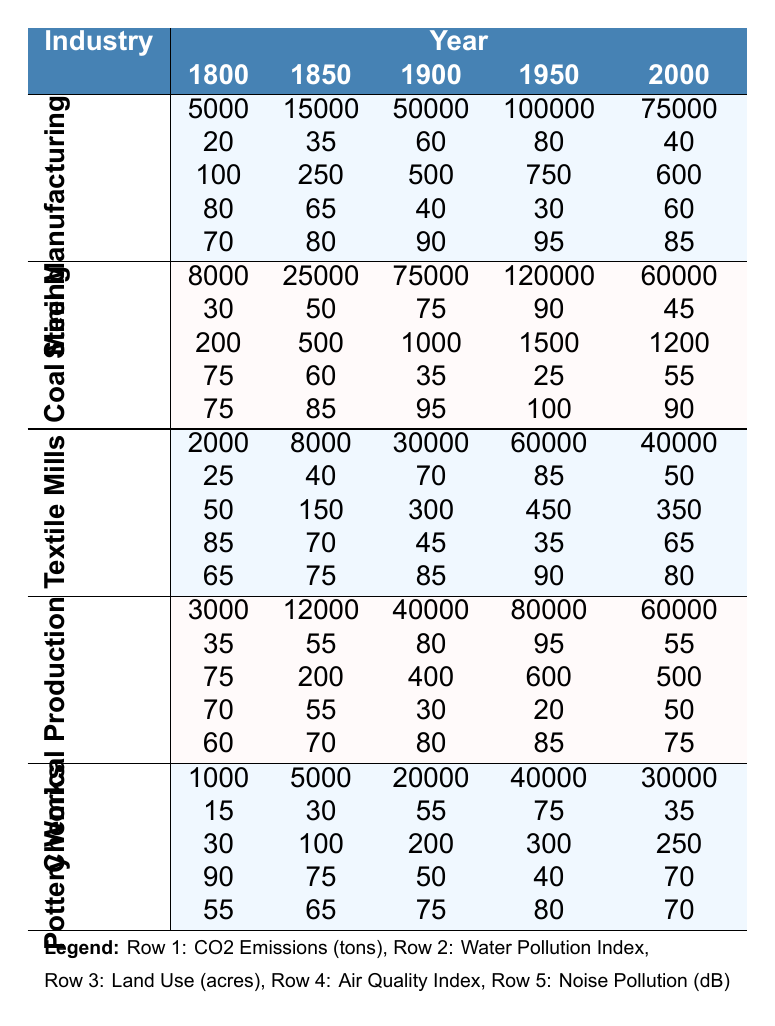What were the CO2 emissions of the Coal Mining industry in 1950? The table indicates that the CO2 emissions for Coal Mining in 1950 are 120,000 tons.
Answer: 120000 tons Which industry had the highest air quality index in 1800? The table shows that Pottery Works had the highest air quality index in 1800, with a value of 90.
Answer: Pottery Works What is the difference in CO2 emissions between Steel Manufacturing in 1900 and in 2000? Steel Manufacturing emitted 50,000 tons in 1900 and 75,000 tons in 2000. The difference is 75,000 - 50,000 = 25,000 tons.
Answer: 25000 tons In which year did Chemical Production record its highest noise pollution levels? Chemical Production reached its highest noise pollution levels of 85 dB in 1950.
Answer: 1950 What is the average water pollution index for Textile Mills across all years? The water pollution indices for Textile Mills are 25, 40, 70, 85, and 50. The average is (25 + 40 + 70 + 85 + 50)/5 = 54.
Answer: 54 Did Coal Mining have a water pollution index higher than 90 in any year? The highest water pollution index for Coal Mining was 90 in 1950, so yes, it did have a value of 90.
Answer: Yes Which industry had the lowest noise pollution levels in 2000? In 2000, the lowest noise pollution level was recorded for Pottery Works at 70 dB.
Answer: Pottery Works What were the total land use acres for Chemical Production from 1800 to 2000? The land use values are 75, 200, 400, 600, and 500 acres. The total land use is 75 + 200 + 400 + 600 + 500 = 1875 acres.
Answer: 1875 acres Is it true that the air quality index for Textile Mills improved from 1900 to 2000? In 1900, the air quality index for Textile Mills was 45, and in 2000 it rose to 65, indicating an improvement.
Answer: Yes What was the trend in CO2 emissions for Pottery Works from 1800 to 2000? The CO2 emissions for Pottery Works increased from 1,000 tons in 1800 to 30,000 tons in 2000, indicating a rising trend.
Answer: Rising trend 